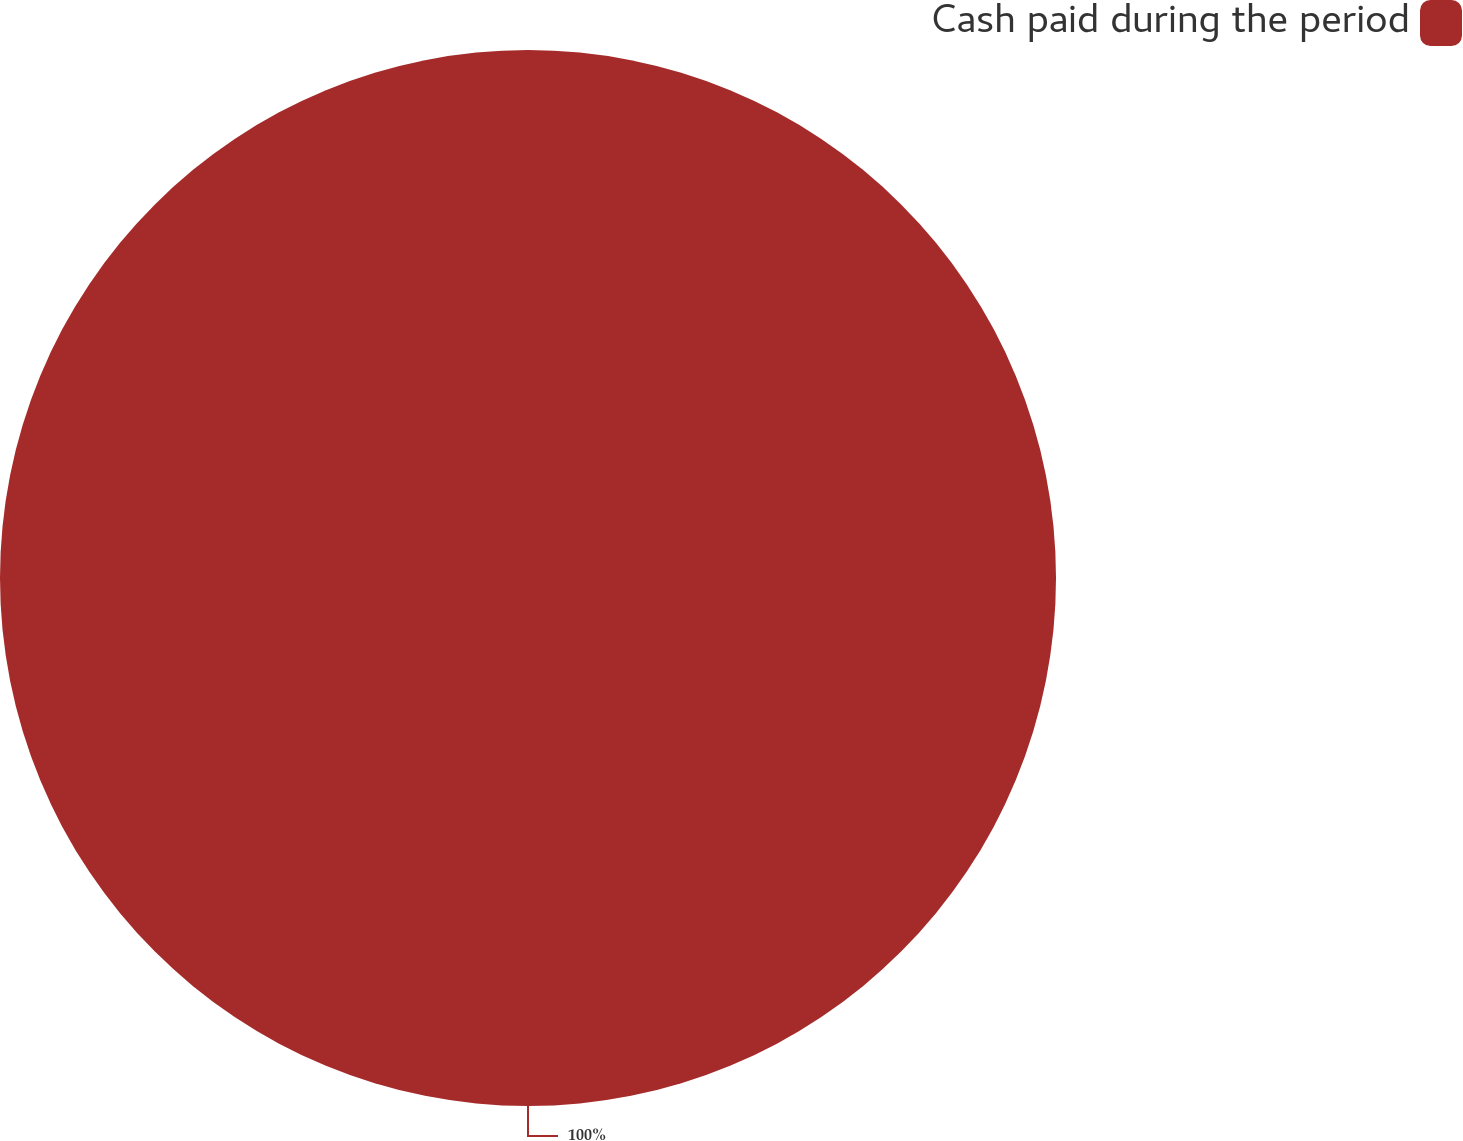<chart> <loc_0><loc_0><loc_500><loc_500><pie_chart><fcel>Cash paid during the period<nl><fcel>100.0%<nl></chart> 